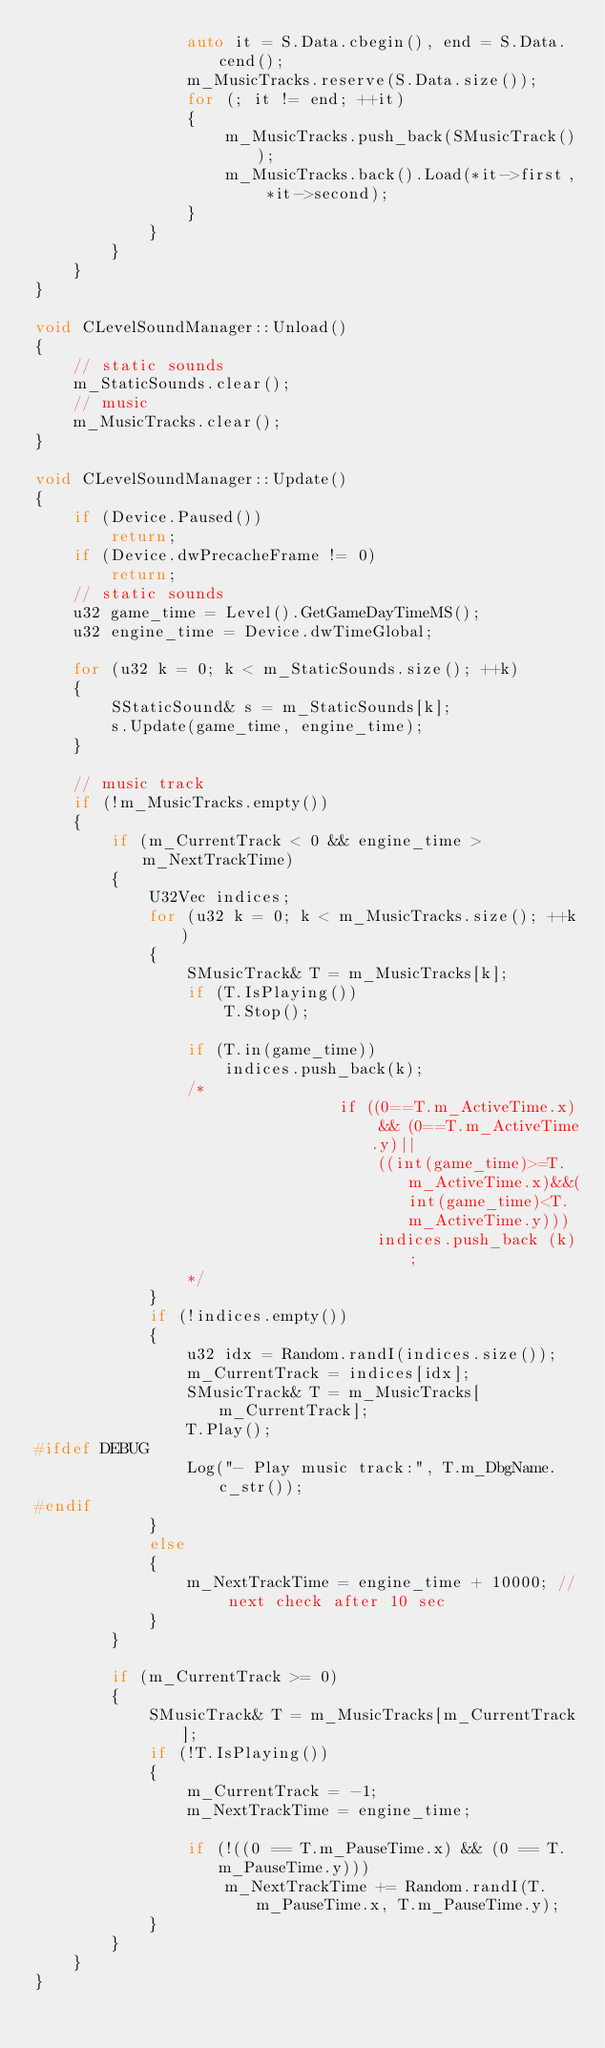Convert code to text. <code><loc_0><loc_0><loc_500><loc_500><_C++_>                auto it = S.Data.cbegin(), end = S.Data.cend();
                m_MusicTracks.reserve(S.Data.size());
                for (; it != end; ++it)
                {
                    m_MusicTracks.push_back(SMusicTrack());
                    m_MusicTracks.back().Load(*it->first, *it->second);
                }
            }
        }
    }
}

void CLevelSoundManager::Unload()
{
    // static sounds
    m_StaticSounds.clear();
    // music
    m_MusicTracks.clear();
}

void CLevelSoundManager::Update()
{
    if (Device.Paused())
        return;
    if (Device.dwPrecacheFrame != 0)
        return;
    // static sounds
    u32 game_time = Level().GetGameDayTimeMS();
    u32 engine_time = Device.dwTimeGlobal;

    for (u32 k = 0; k < m_StaticSounds.size(); ++k)
    {
        SStaticSound& s = m_StaticSounds[k];
        s.Update(game_time, engine_time);
    }

    // music track
    if (!m_MusicTracks.empty())
    {
        if (m_CurrentTrack < 0 && engine_time > m_NextTrackTime)
        {
            U32Vec indices;
            for (u32 k = 0; k < m_MusicTracks.size(); ++k)
            {
                SMusicTrack& T = m_MusicTracks[k];
                if (T.IsPlaying())
                    T.Stop();

                if (T.in(game_time))
                    indices.push_back(k);
                /*
                                if ((0==T.m_ActiveTime.x) && (0==T.m_ActiveTime.y)||
                                    ((int(game_time)>=T.m_ActiveTime.x)&&(int(game_time)<T.m_ActiveTime.y)))
                                    indices.push_back	(k);
                */
            }
            if (!indices.empty())
            {
                u32 idx = Random.randI(indices.size());
                m_CurrentTrack = indices[idx];
                SMusicTrack& T = m_MusicTracks[m_CurrentTrack];
                T.Play();
#ifdef DEBUG
                Log("- Play music track:", T.m_DbgName.c_str());
#endif
            }
            else
            {
                m_NextTrackTime = engine_time + 10000; // next check after 10 sec
            }
        }

        if (m_CurrentTrack >= 0)
        {
            SMusicTrack& T = m_MusicTracks[m_CurrentTrack];
            if (!T.IsPlaying())
            {
                m_CurrentTrack = -1;
                m_NextTrackTime = engine_time;

                if (!((0 == T.m_PauseTime.x) && (0 == T.m_PauseTime.y)))
                    m_NextTrackTime += Random.randI(T.m_PauseTime.x, T.m_PauseTime.y);
            }
        }
    }
}
</code> 